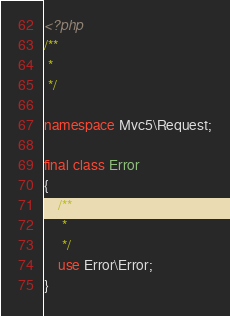Convert code to text. <code><loc_0><loc_0><loc_500><loc_500><_PHP_><?php
/**
 *
 */

namespace Mvc5\Request;

final class Error
{
    /**
     *
     */
    use Error\Error;
}
</code> 